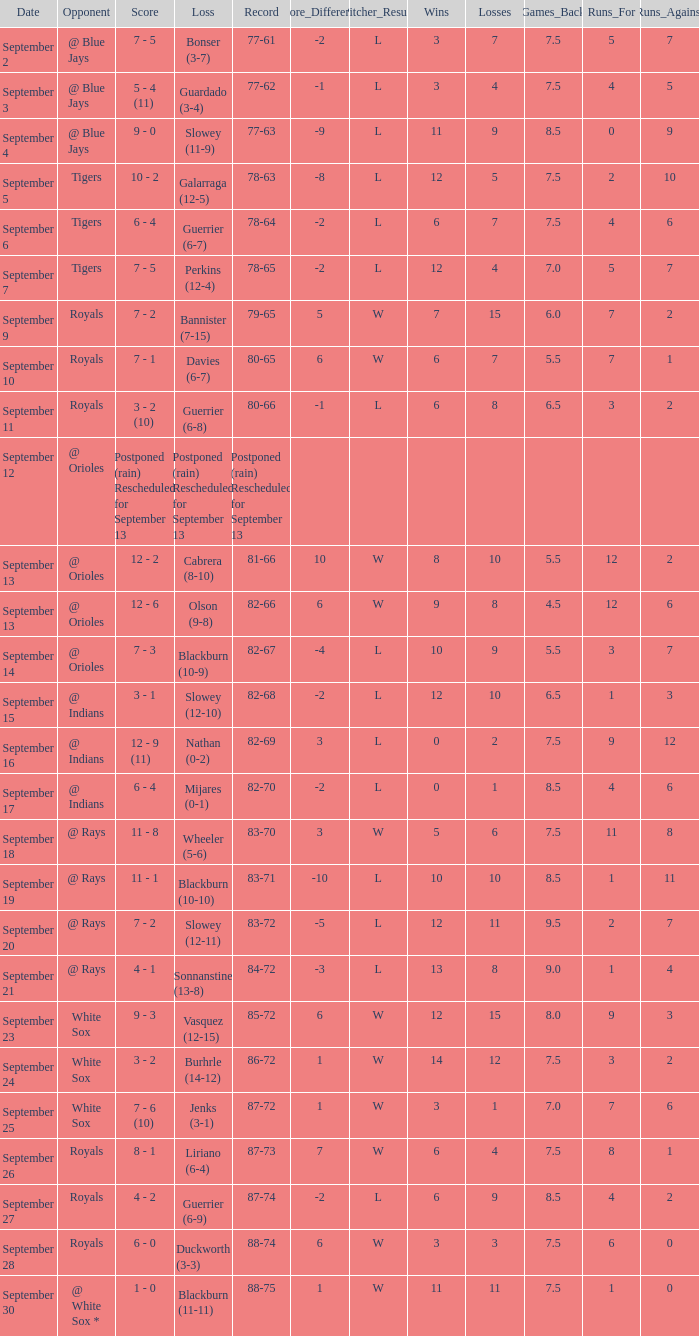What date has the record of 77-62? September 3. 